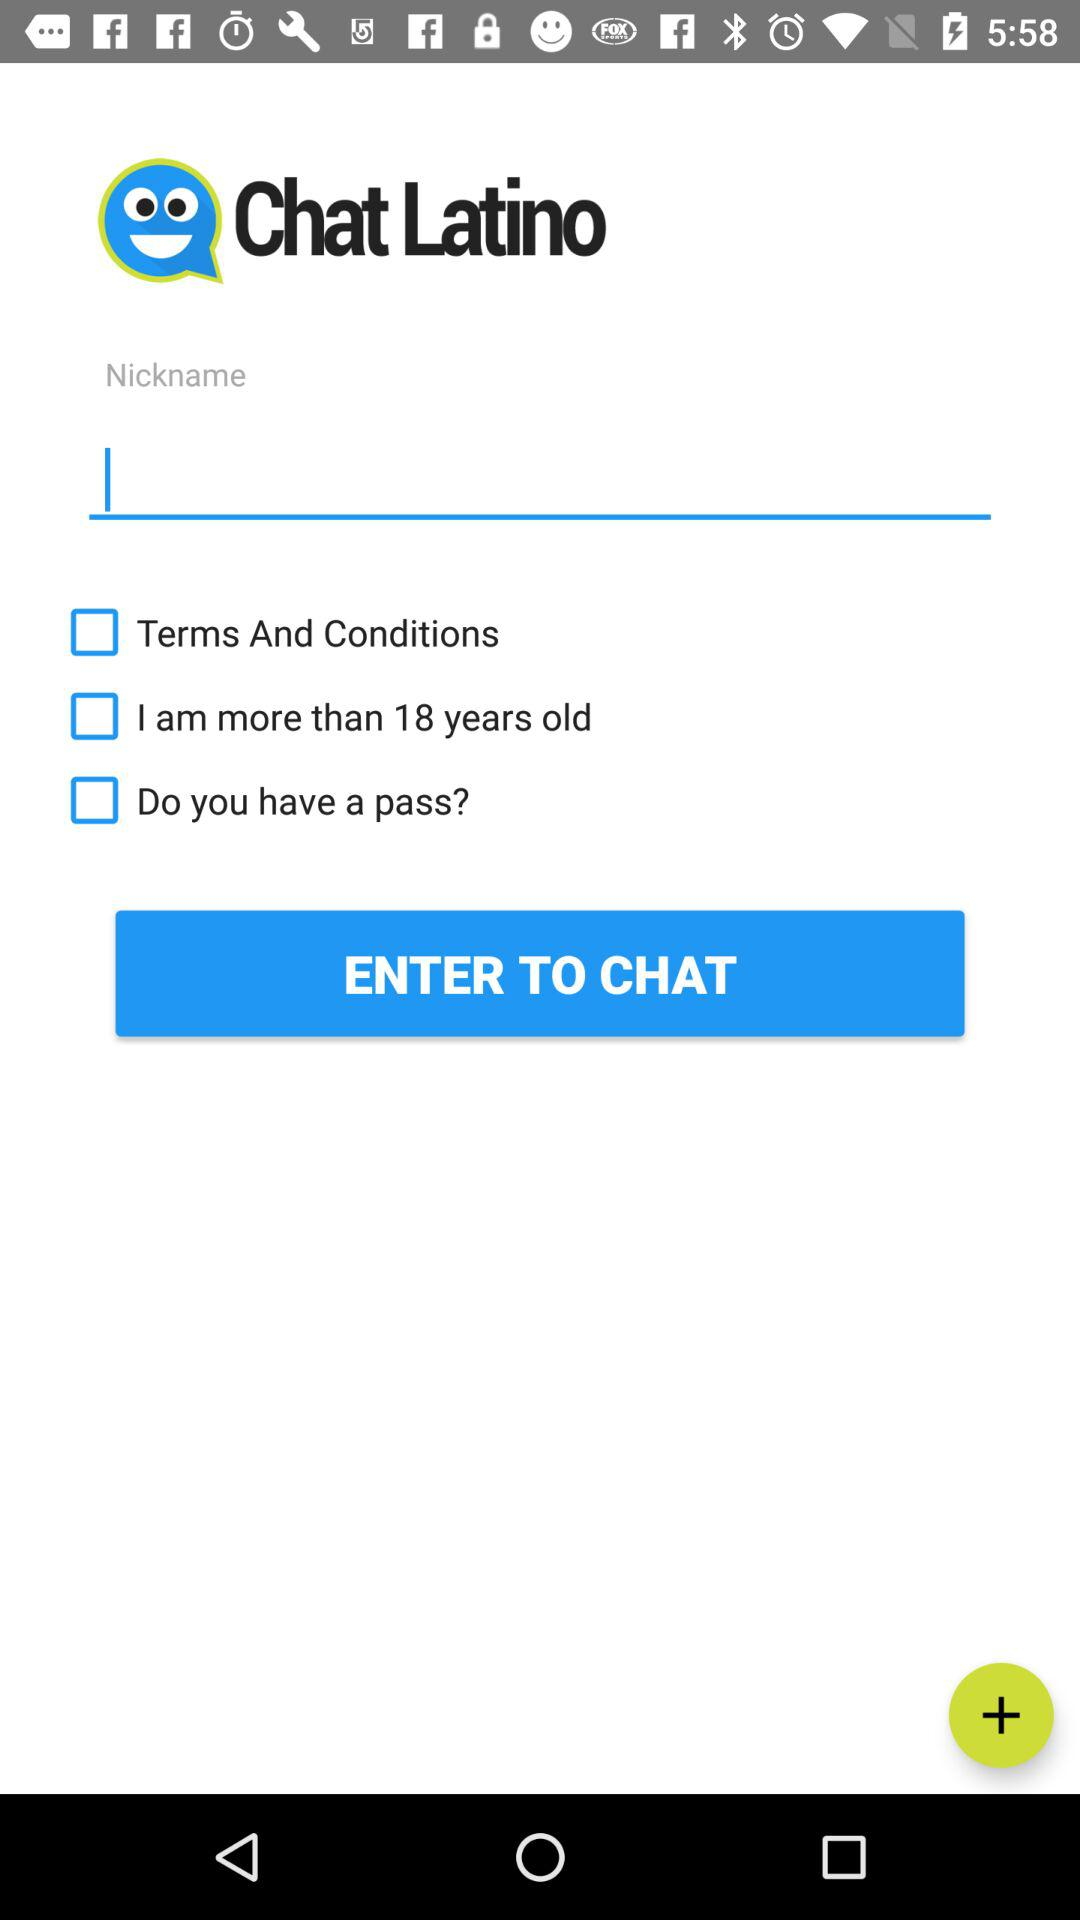What is the name of the application? The name of the application is "Chat Latino". 